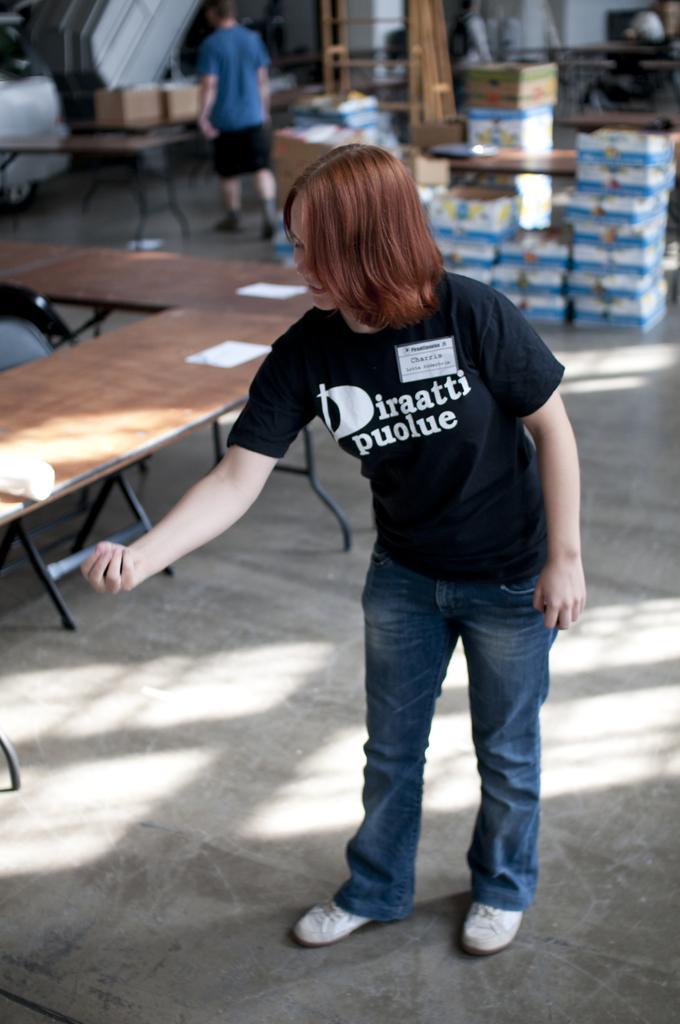In one or two sentences, can you explain what this image depicts? As we can see in the image there are tables and two people standing over here and on tables there are boxes. 